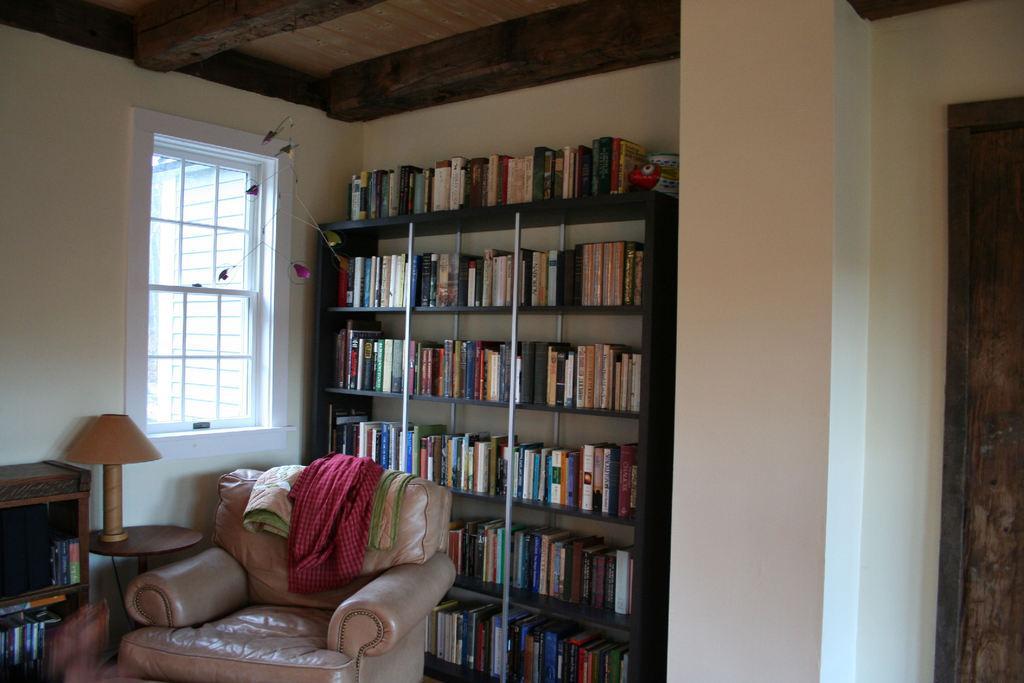Could you give a brief overview of what you see in this image? In this image we can see a sofa with some clothes on it, a cupboard with some books and a lamp on a table. We can also see a group of books placed in the shelves, a window, roof, door and a wall. 